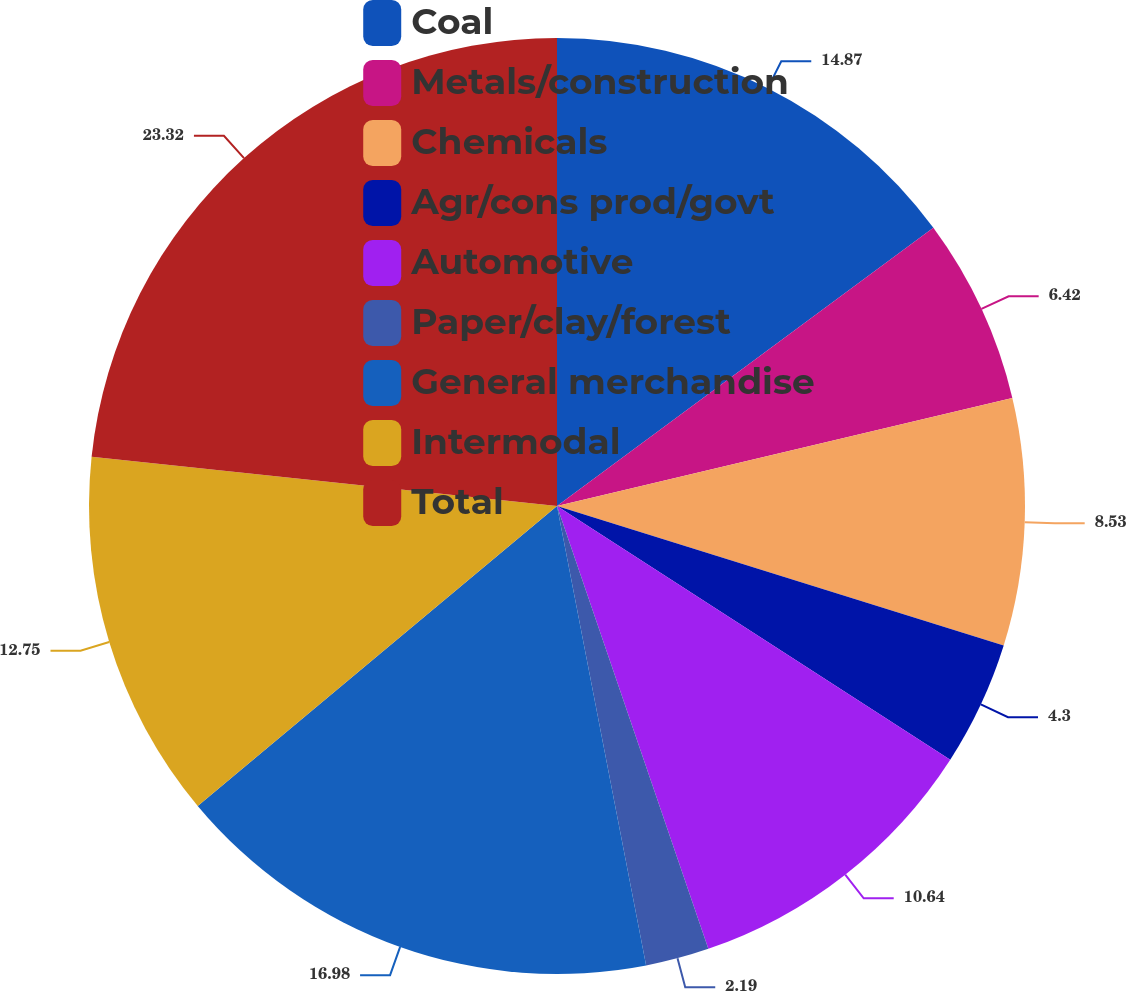Convert chart. <chart><loc_0><loc_0><loc_500><loc_500><pie_chart><fcel>Coal<fcel>Metals/construction<fcel>Chemicals<fcel>Agr/cons prod/govt<fcel>Automotive<fcel>Paper/clay/forest<fcel>General merchandise<fcel>Intermodal<fcel>Total<nl><fcel>14.87%<fcel>6.42%<fcel>8.53%<fcel>4.3%<fcel>10.64%<fcel>2.19%<fcel>16.98%<fcel>12.75%<fcel>23.32%<nl></chart> 